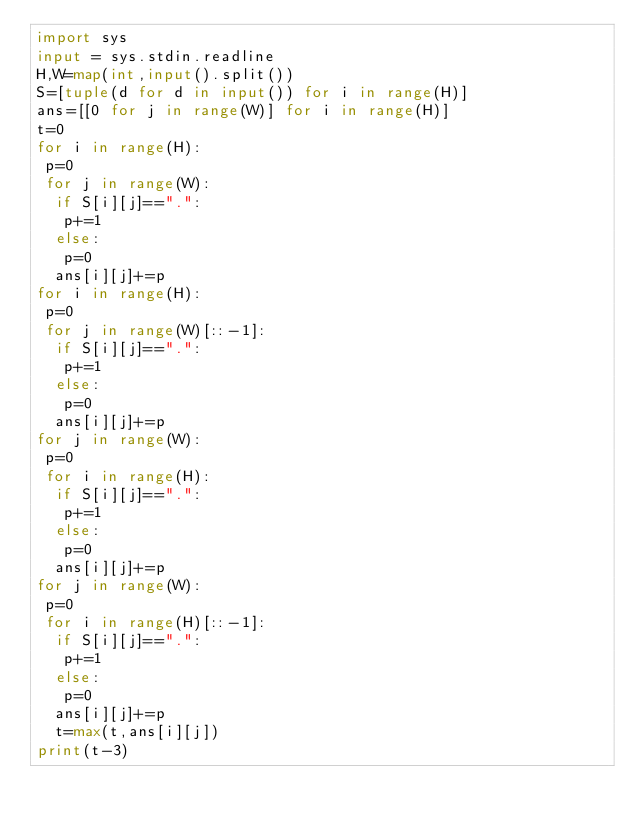Convert code to text. <code><loc_0><loc_0><loc_500><loc_500><_Python_>import sys
input = sys.stdin.readline
H,W=map(int,input().split())
S=[tuple(d for d in input()) for i in range(H)]
ans=[[0 for j in range(W)] for i in range(H)]
t=0
for i in range(H):
 p=0
 for j in range(W):
  if S[i][j]==".":
   p+=1
  else:
   p=0
  ans[i][j]+=p
for i in range(H):
 p=0
 for j in range(W)[::-1]:
  if S[i][j]==".":
   p+=1
  else:
   p=0
  ans[i][j]+=p
for j in range(W):
 p=0
 for i in range(H):
  if S[i][j]==".":
   p+=1
  else:
   p=0
  ans[i][j]+=p
for j in range(W):
 p=0
 for i in range(H)[::-1]:
  if S[i][j]==".":
   p+=1
  else:
   p=0
  ans[i][j]+=p
  t=max(t,ans[i][j])
print(t-3)</code> 